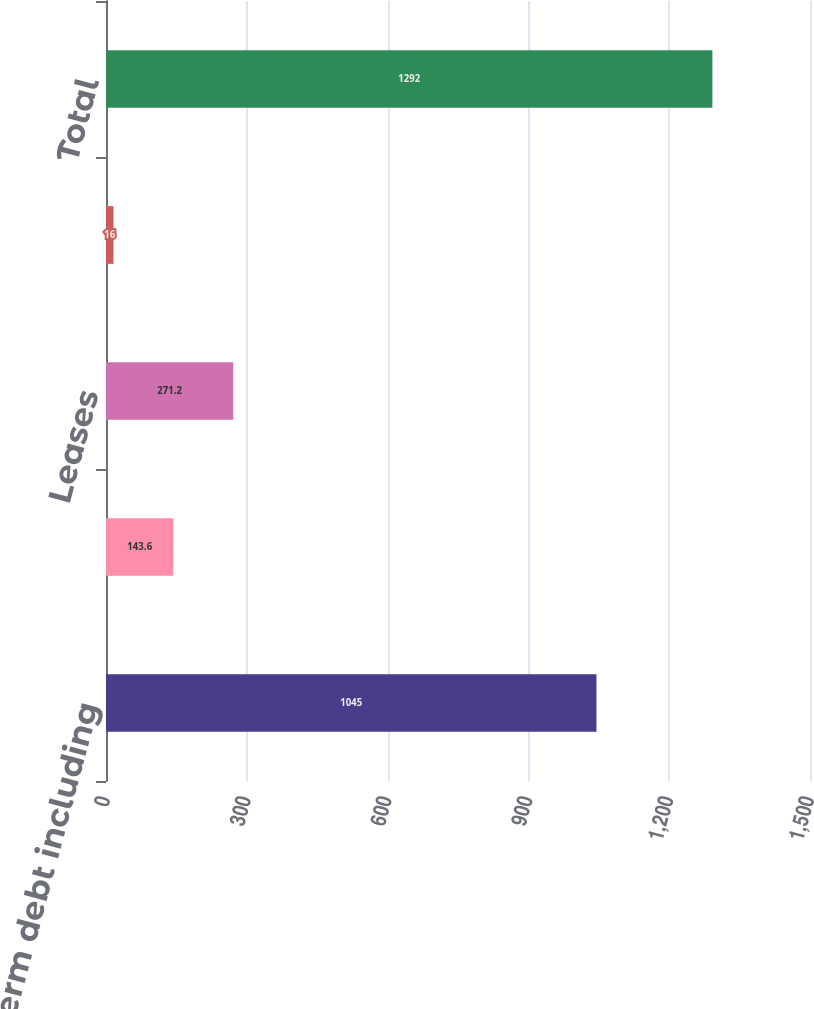Convert chart. <chart><loc_0><loc_0><loc_500><loc_500><bar_chart><fcel>Long-term debt including<fcel>Net cash interest payments on<fcel>Leases<fcel>Purchase obligations (2)<fcel>Total<nl><fcel>1045<fcel>143.6<fcel>271.2<fcel>16<fcel>1292<nl></chart> 